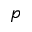<formula> <loc_0><loc_0><loc_500><loc_500>p</formula> 